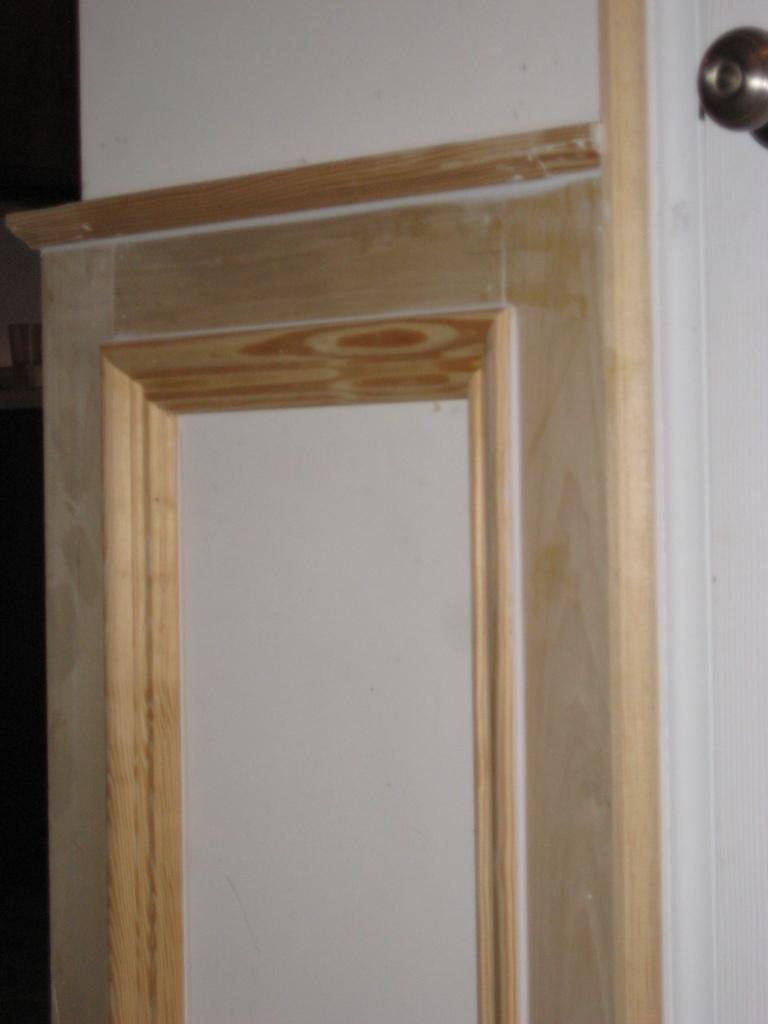What is present on the wall in the image? There is a wall with wooden plating in the image. Can you describe any specific features on the wall? Yes, there is a knob on the right side of the image. How many snowflakes can be seen on the wall in the image? There are no snowflakes present on the wall in the image. What type of bead is hanging from the knob in the image? There is no bead hanging from the knob in the image. 